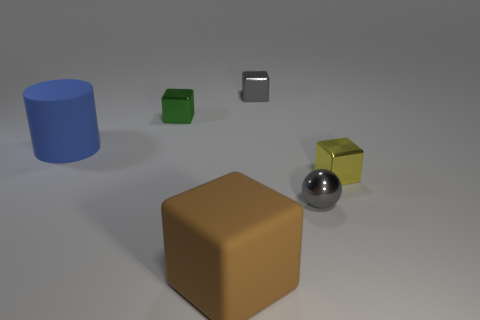There is a large object that is the same shape as the small yellow metallic thing; what is its color?
Provide a succinct answer. Brown. There is a object that is in front of the tiny yellow object and to the right of the small gray shiny cube; what is its shape?
Provide a short and direct response. Sphere. Is the big thing behind the big block made of the same material as the small green block?
Your answer should be very brief. No. What number of objects are metallic balls or objects behind the brown cube?
Offer a very short reply. 5. There is a tiny sphere that is made of the same material as the yellow cube; what is its color?
Ensure brevity in your answer.  Gray. How many blue things are the same material as the tiny yellow thing?
Your answer should be compact. 0. How many gray objects are there?
Your answer should be very brief. 2. Is the color of the large block that is to the right of the big matte cylinder the same as the metal cube right of the small gray shiny ball?
Your answer should be compact. No. There is a green object; what number of tiny gray blocks are on the right side of it?
Ensure brevity in your answer.  1. There is a tiny block that is the same color as the small sphere; what material is it?
Keep it short and to the point. Metal. 